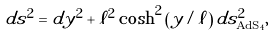Convert formula to latex. <formula><loc_0><loc_0><loc_500><loc_500>d s ^ { 2 } = d y ^ { 2 } + \ell ^ { 2 } \cosh ^ { 2 } \left ( y / \ell \right ) d s ^ { 2 } _ { \text {AdS} _ { 4 } } ,</formula> 